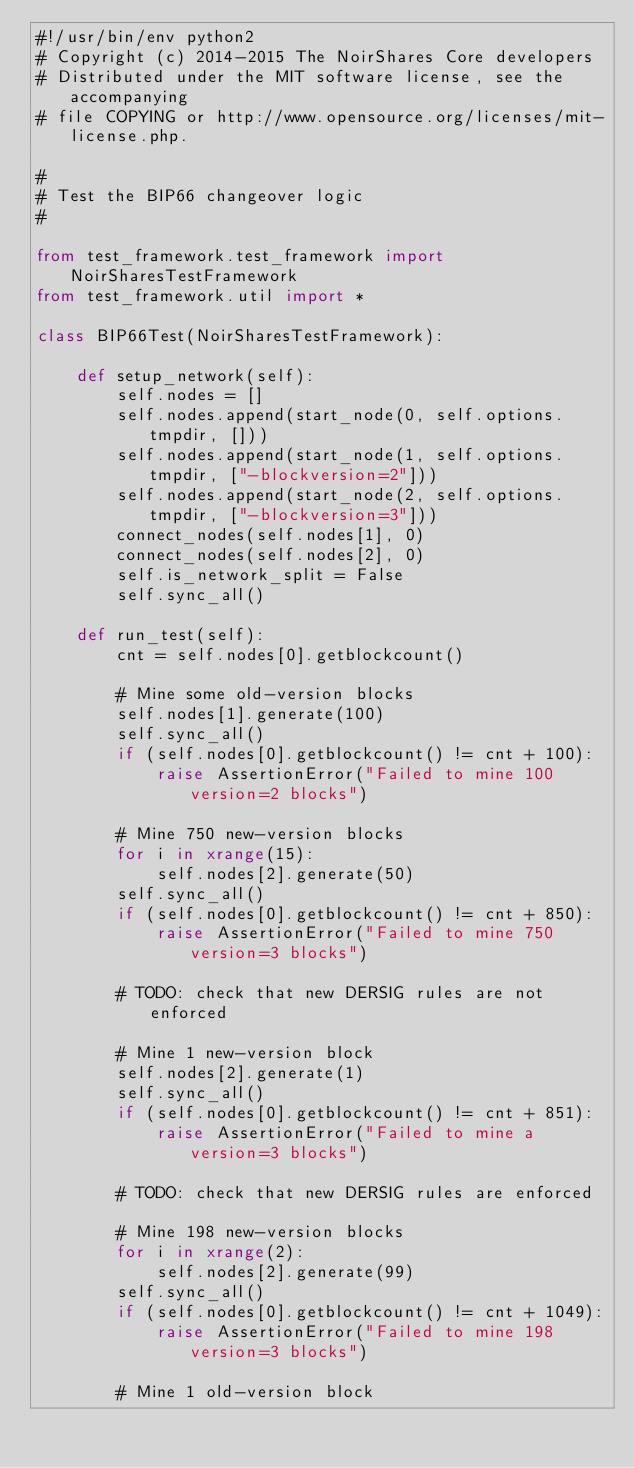Convert code to text. <code><loc_0><loc_0><loc_500><loc_500><_Python_>#!/usr/bin/env python2
# Copyright (c) 2014-2015 The NoirShares Core developers
# Distributed under the MIT software license, see the accompanying
# file COPYING or http://www.opensource.org/licenses/mit-license.php.

#
# Test the BIP66 changeover logic
#

from test_framework.test_framework import NoirSharesTestFramework
from test_framework.util import *

class BIP66Test(NoirSharesTestFramework):

    def setup_network(self):
        self.nodes = []
        self.nodes.append(start_node(0, self.options.tmpdir, []))
        self.nodes.append(start_node(1, self.options.tmpdir, ["-blockversion=2"]))
        self.nodes.append(start_node(2, self.options.tmpdir, ["-blockversion=3"]))
        connect_nodes(self.nodes[1], 0)
        connect_nodes(self.nodes[2], 0)
        self.is_network_split = False
        self.sync_all()

    def run_test(self):
        cnt = self.nodes[0].getblockcount()

        # Mine some old-version blocks
        self.nodes[1].generate(100)
        self.sync_all()
        if (self.nodes[0].getblockcount() != cnt + 100):
            raise AssertionError("Failed to mine 100 version=2 blocks")

        # Mine 750 new-version blocks
        for i in xrange(15):
            self.nodes[2].generate(50)
        self.sync_all()
        if (self.nodes[0].getblockcount() != cnt + 850):
            raise AssertionError("Failed to mine 750 version=3 blocks")

        # TODO: check that new DERSIG rules are not enforced

        # Mine 1 new-version block
        self.nodes[2].generate(1)
        self.sync_all()
        if (self.nodes[0].getblockcount() != cnt + 851):
            raise AssertionError("Failed to mine a version=3 blocks")

        # TODO: check that new DERSIG rules are enforced

        # Mine 198 new-version blocks
        for i in xrange(2):
            self.nodes[2].generate(99)
        self.sync_all()
        if (self.nodes[0].getblockcount() != cnt + 1049):
            raise AssertionError("Failed to mine 198 version=3 blocks")

        # Mine 1 old-version block</code> 